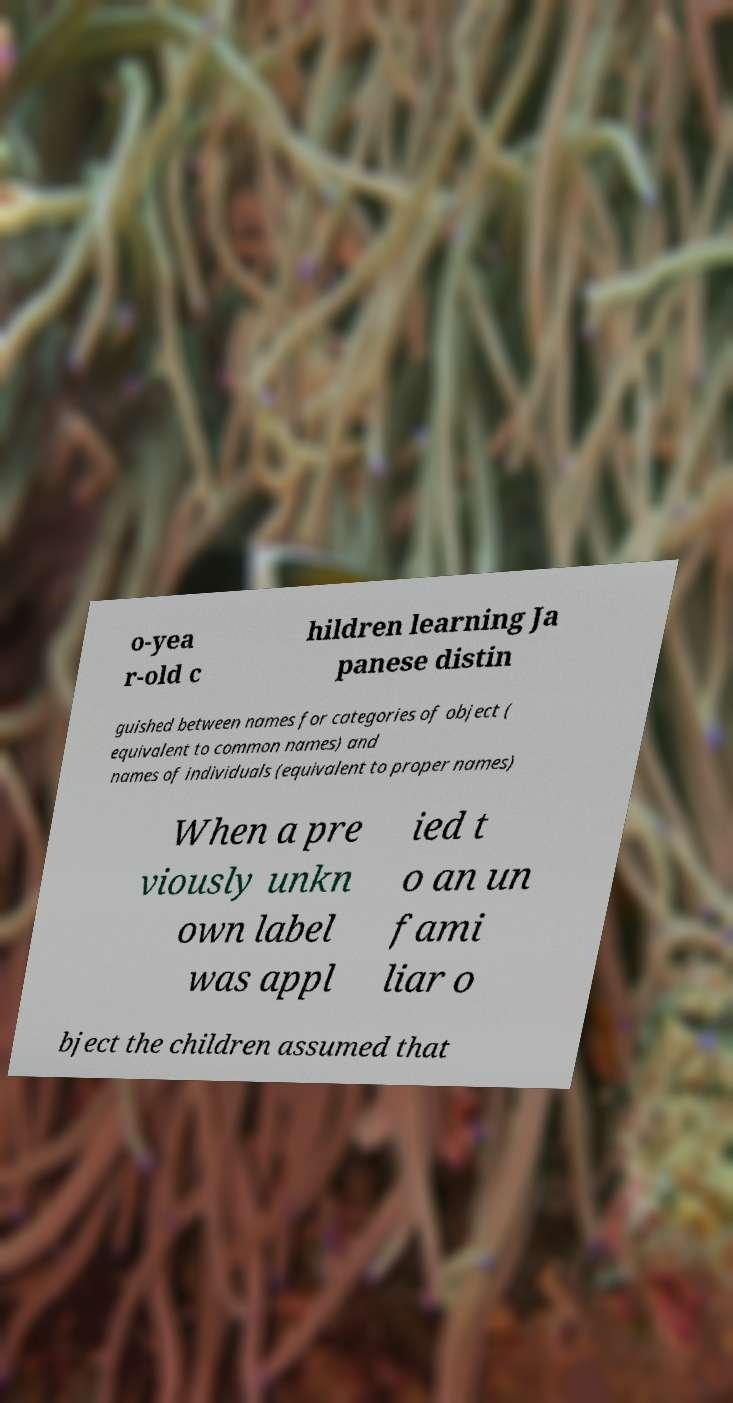Please identify and transcribe the text found in this image. o-yea r-old c hildren learning Ja panese distin guished between names for categories of object ( equivalent to common names) and names of individuals (equivalent to proper names) When a pre viously unkn own label was appl ied t o an un fami liar o bject the children assumed that 